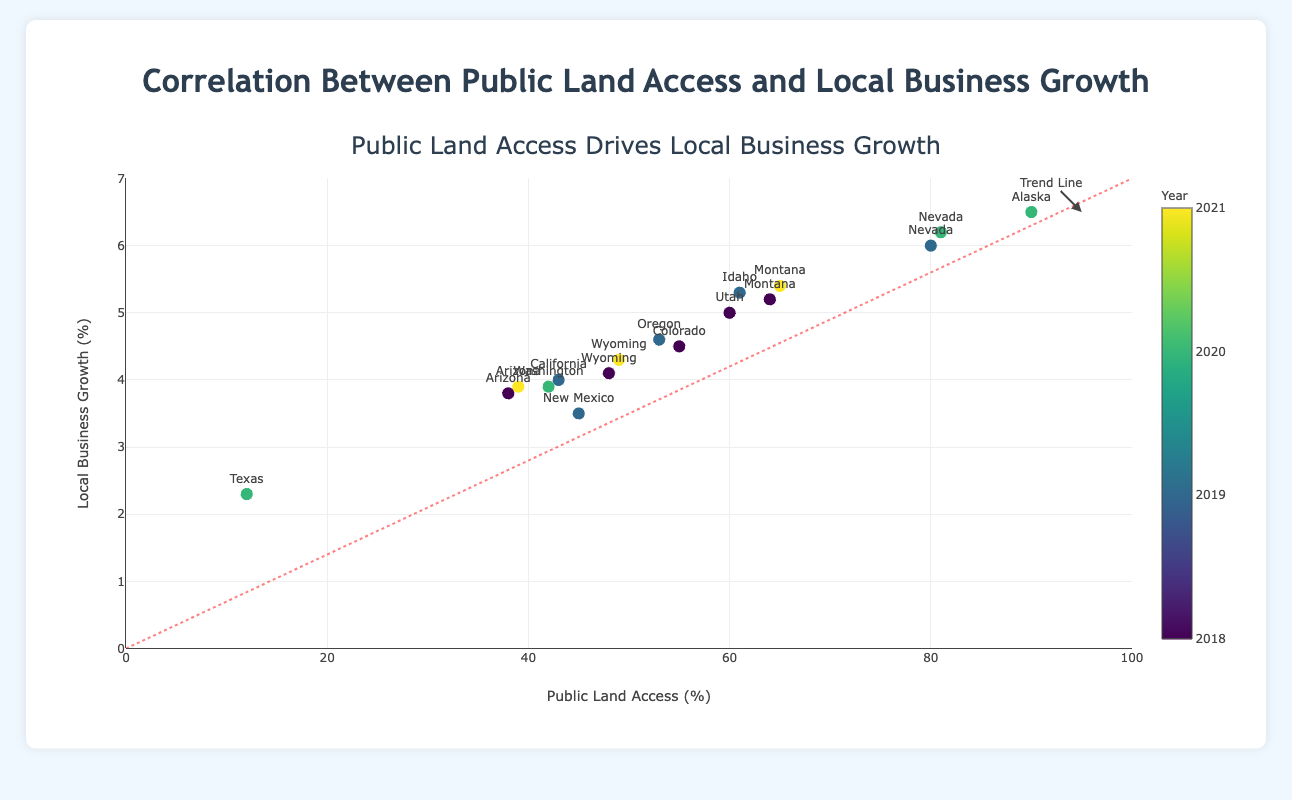What state had the highest local business growth in 2020? The figure shows that Alaska had the highest local business growth in 2020 at 6.5%.
Answer: Alaska What is the average local business growth for states with more than 60% public land access? The states with more than 60% public land access are Nevada (80%), Alaska (90%), and Nevada (81%). Their local business growths are 6.0%, 6.5%, and 6.2%. Average = (6.0 + 6.5 + 6.2) / 3 = 6.23%
Answer: 6.23% Which state with at least 50% public land access had the lowest business growth? The states with at least 50% public land access are Colorado (55%), Montana (64%), Utah (60%), Idaho (61%), and Oregon (53%). The state with the lowest business growth among these is Colorado with 4.5%.
Answer: Colorado How does the business growth in 2019 for California compare to that in 2020 for Washington? California in 2019 had a business growth of 4.0%, while Washington in 2020 had a business growth of 3.9%. California's growth was slightly higher by 0.1%.
Answer: California's growth was 0.1% higher Describe the trend line visually presented on the plot. The trend line starts from the origin (0, 0) and diagonally rises to (100, 7) indicating that as public land access increases, local business growth also increases, demonstrating a positive correlation.
Answer: Positive correlation Which year has the highest concentration of data points in the plot? By examining the colors that represent the years, 2019 has the highest concentration of data points in the plot.
Answer: 2019 Identify the state that showed an increased local business growth from 2018 to 2021. Montana is the state shown, as its growth increased from 5.2% in 2018 to 5.4% in 2021.
Answer: Montana Which state had the highest public land access and what was the corresponding local business growth? According to the plot, Alaska had the highest public land access at 90%, with a corresponding local business growth of 6.5%.
Answer: Alaska with 6.5% What is the median public land access percentage of all states in 2019? The public land access percentages for states in 2019 are New Mexico (45%), Nevada (80%), California (43%), Idaho (61%), and Oregon (53%). When sorted: 43, 45, 53, 61, 80. The median value is 53%.
Answer: 53% What is the increase in local business growth from 2019 to 2020 for Nevada? Nevada's local business growth in 2019 was 6.0%, and in 2020 it was 6.2%. The increase is 6.2% - 6.0% = 0.2%.
Answer: 0.2% 